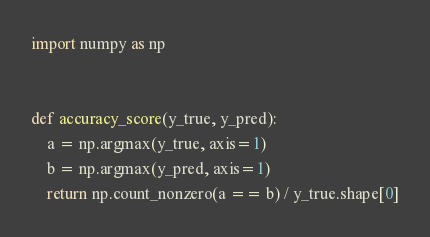<code> <loc_0><loc_0><loc_500><loc_500><_Python_>import numpy as np


def accuracy_score(y_true, y_pred):
    a = np.argmax(y_true, axis=1)
    b = np.argmax(y_pred, axis=1)
    return np.count_nonzero(a == b) / y_true.shape[0]
</code> 